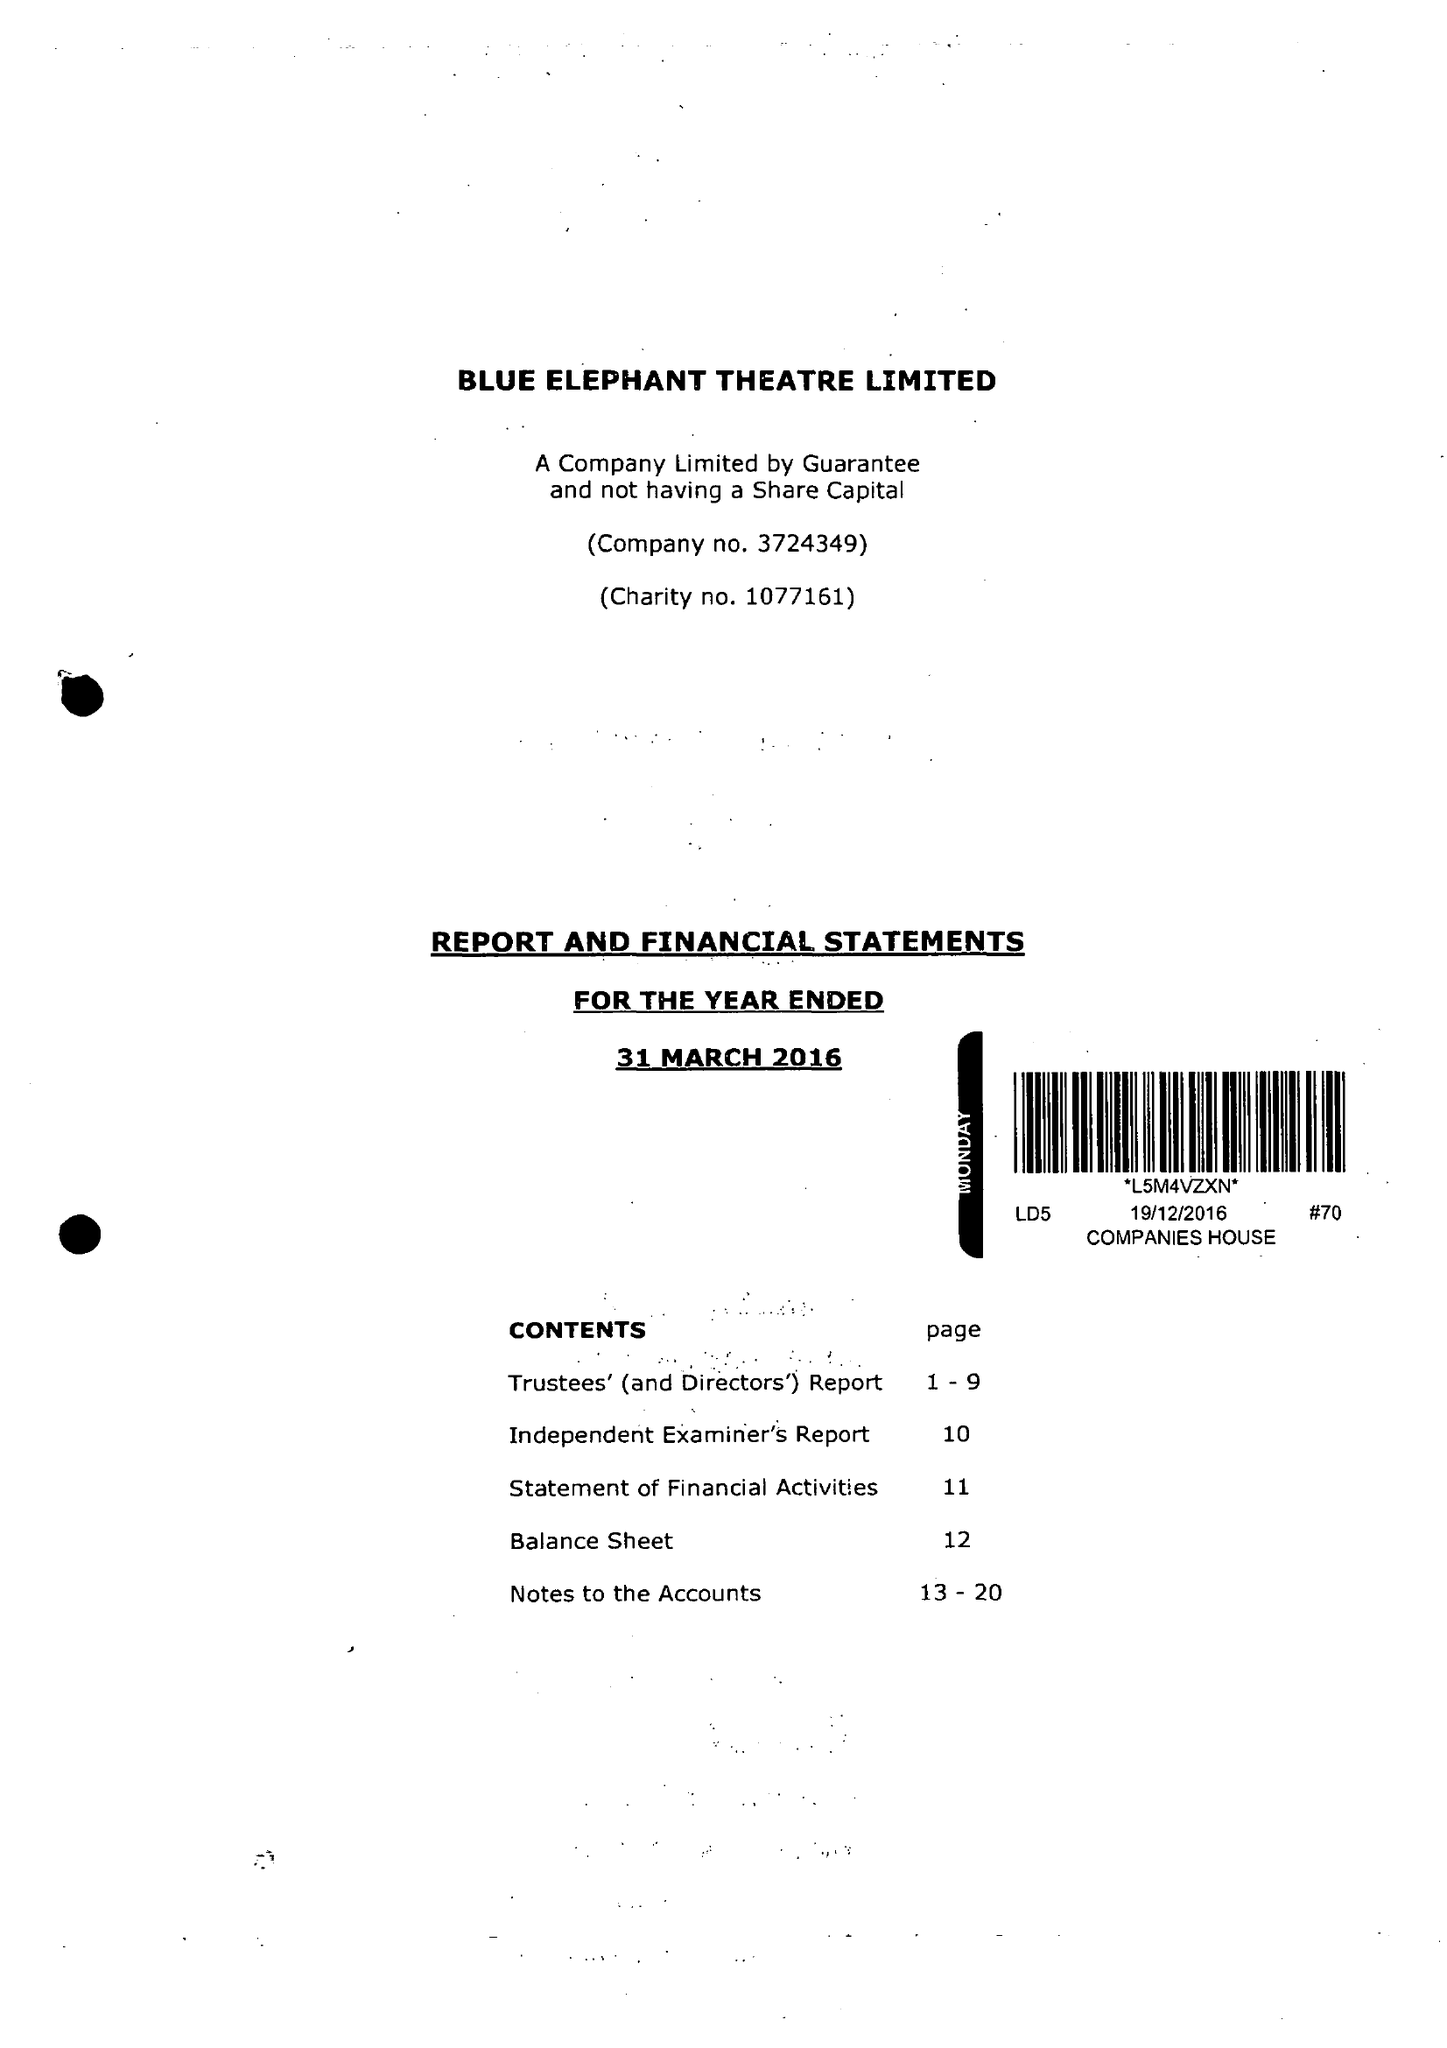What is the value for the address__street_line?
Answer the question using a single word or phrase. 59A BETHWIN ROAD 